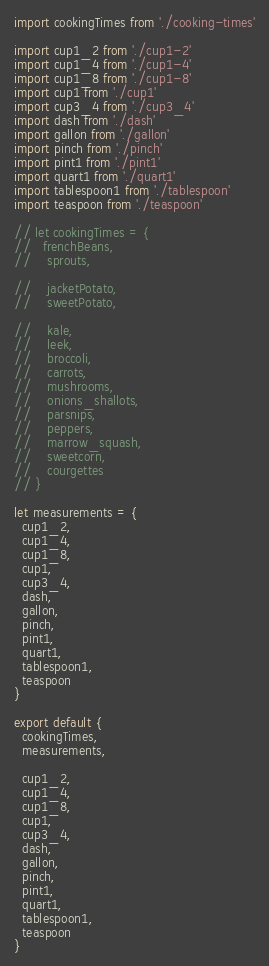Convert code to text. <code><loc_0><loc_0><loc_500><loc_500><_JavaScript_>import cookingTimes from './cooking-times'

import cup1_2 from './cup1-2'
import cup1_4 from './cup1-4'
import cup1_8 from './cup1-8'
import cup1 from './cup1'
import cup3_4 from './cup3_4'
import dash from './dash'
import gallon from './gallon'
import pinch from './pinch'
import pint1 from './pint1'
import quart1 from './quart1'
import tablespoon1 from './tablespoon'
import teaspoon from './teaspoon'

// let cookingTimes = {
//   frenchBeans,
//    sprouts,

//    jacketPotato,
//    sweetPotato,

//    kale,
//    leek,
//    broccoli,
//    carrots,
//    mushrooms,
//    onions_shallots,
//    parsnips,
//    peppers,
//    marrow_squash,
//    sweetcorn,
//    courgettes
// }

let measurements = {
  cup1_2,
  cup1_4,
  cup1_8,
  cup1,
  cup3_4,
  dash,
  gallon,
  pinch,
  pint1,
  quart1,
  tablespoon1,
  teaspoon
}

export default {
  cookingTimes,
  measurements,

  cup1_2,
  cup1_4,
  cup1_8,
  cup1,
  cup3_4,
  dash,
  gallon,
  pinch,
  pint1,
  quart1,
  tablespoon1,
  teaspoon
}
</code> 